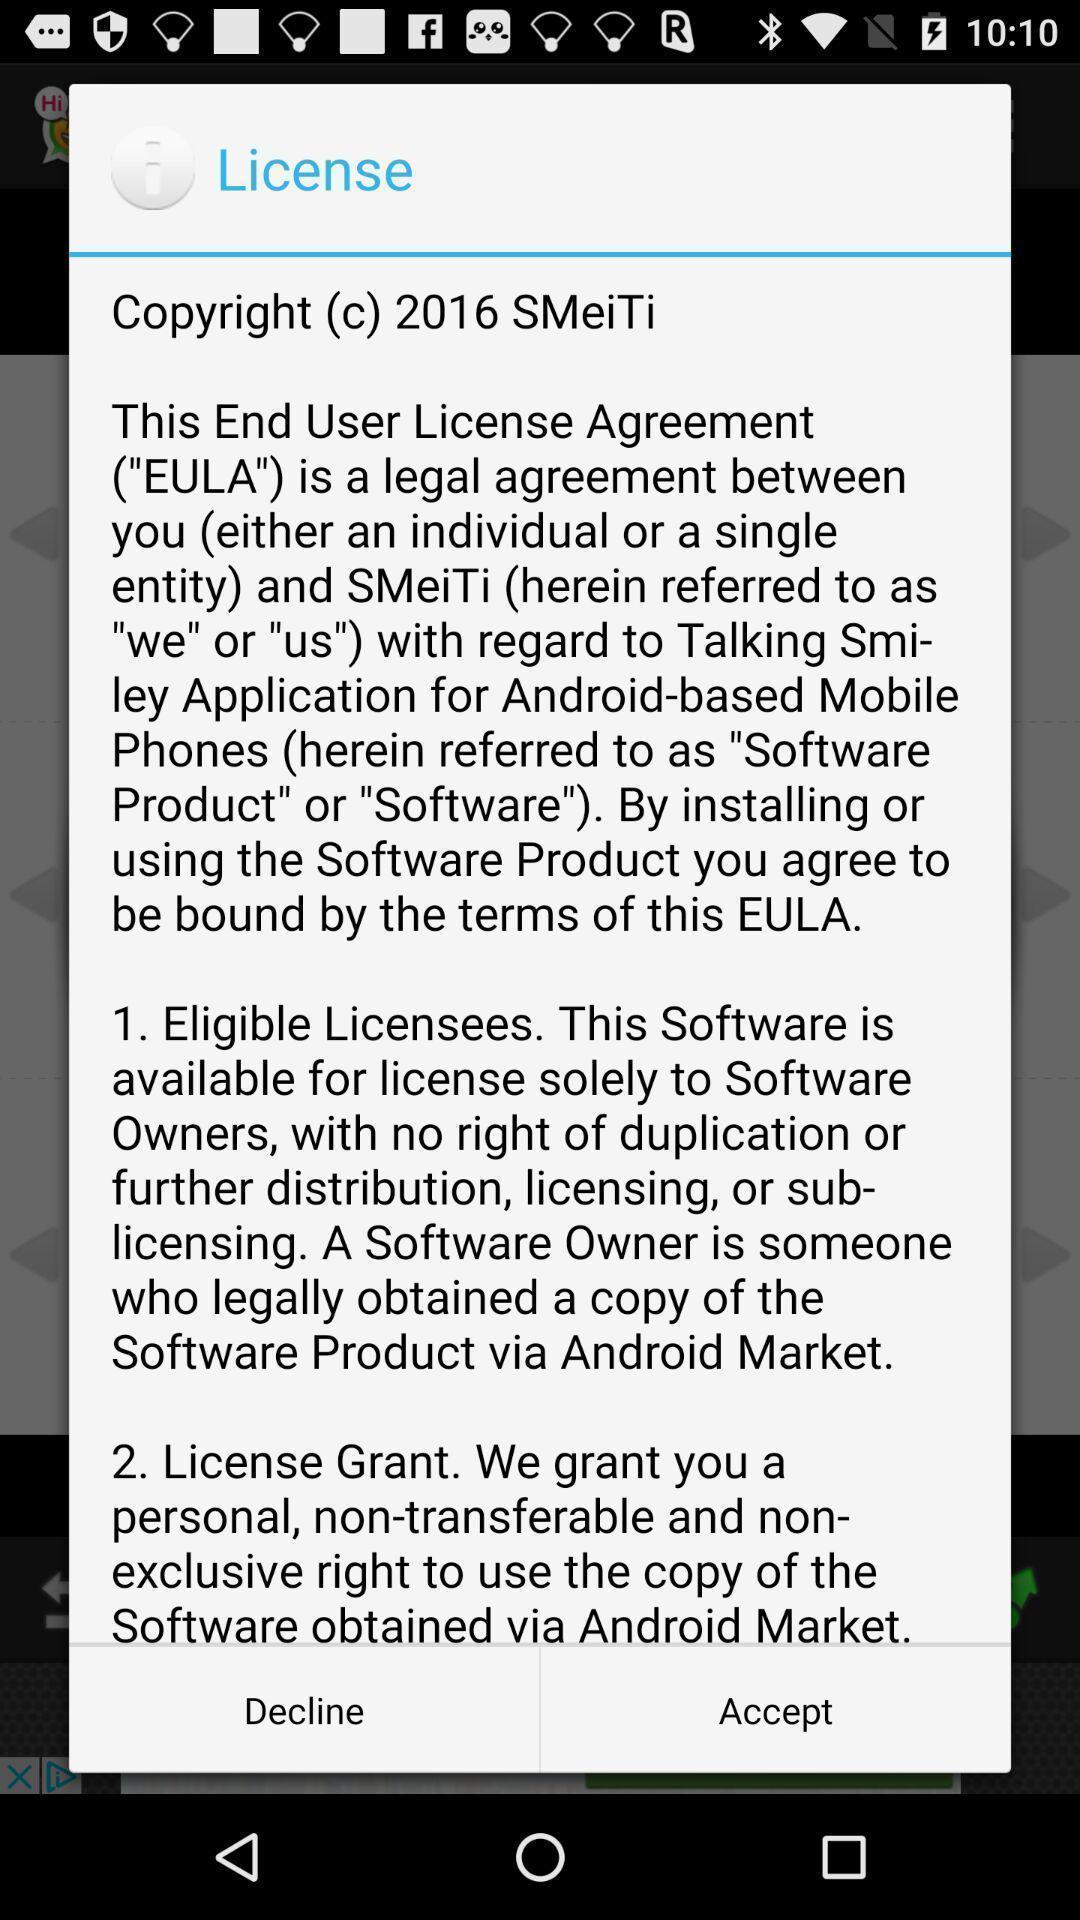Summarize the information in this screenshot. Pop-up showing legal information about application. 